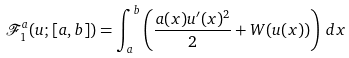<formula> <loc_0><loc_0><loc_500><loc_500>\mathcal { F } ^ { a } _ { 1 } ( u ; [ a , b ] ) = \int _ { a } ^ { b } \left ( \frac { a ( x ) u ^ { \prime } ( x ) ^ { 2 } } { 2 } + W ( u ( x ) ) \right ) \, d x</formula> 